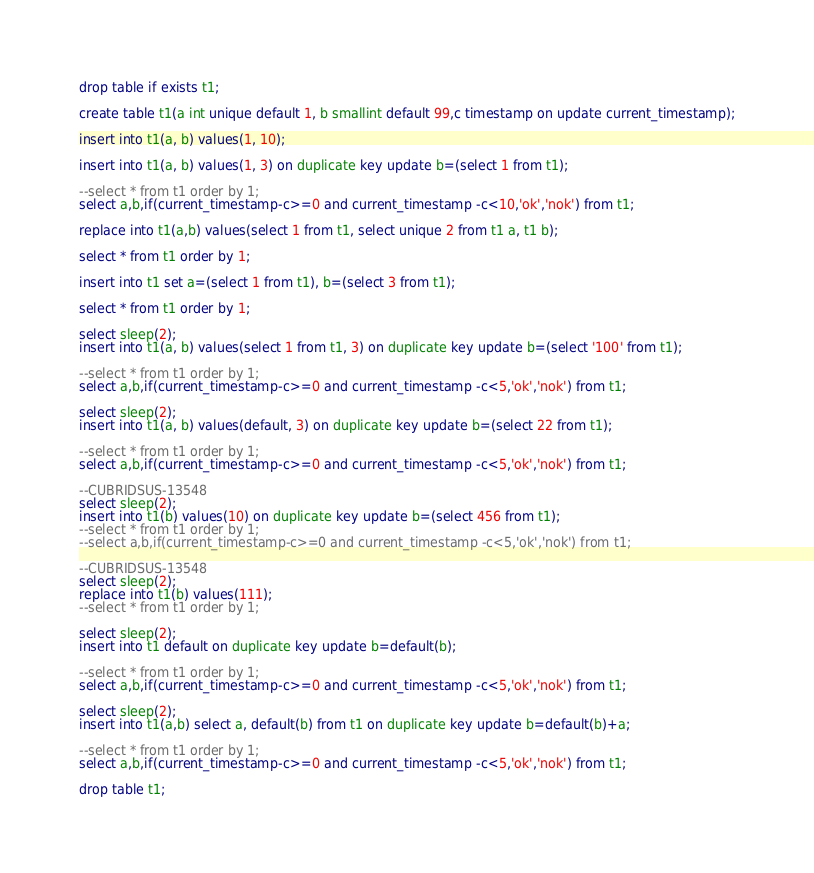Convert code to text. <code><loc_0><loc_0><loc_500><loc_500><_SQL_>drop table if exists t1;

create table t1(a int unique default 1, b smallint default 99,c timestamp on update current_timestamp);

insert into t1(a, b) values(1, 10);

insert into t1(a, b) values(1, 3) on duplicate key update b=(select 1 from t1);

--select * from t1 order by 1;
select a,b,if(current_timestamp-c>=0 and current_timestamp -c<10,'ok','nok') from t1;

replace into t1(a,b) values(select 1 from t1, select unique 2 from t1 a, t1 b);

select * from t1 order by 1;

insert into t1 set a=(select 1 from t1), b=(select 3 from t1);

select * from t1 order by 1;

select sleep(2);
insert into t1(a, b) values(select 1 from t1, 3) on duplicate key update b=(select '100' from t1);

--select * from t1 order by 1;
select a,b,if(current_timestamp-c>=0 and current_timestamp -c<5,'ok','nok') from t1;

select sleep(2);
insert into t1(a, b) values(default, 3) on duplicate key update b=(select 22 from t1);

--select * from t1 order by 1;
select a,b,if(current_timestamp-c>=0 and current_timestamp -c<5,'ok','nok') from t1;

--CUBRIDSUS-13548
select sleep(2);
insert into t1(b) values(10) on duplicate key update b=(select 456 from t1);
--select * from t1 order by 1;
--select a,b,if(current_timestamp-c>=0 and current_timestamp -c<5,'ok','nok') from t1;

--CUBRIDSUS-13548
select sleep(2);
replace into t1(b) values(111);
--select * from t1 order by 1;

select sleep(2);
insert into t1 default on duplicate key update b=default(b);

--select * from t1 order by 1;
select a,b,if(current_timestamp-c>=0 and current_timestamp -c<5,'ok','nok') from t1;

select sleep(2);
insert into t1(a,b) select a, default(b) from t1 on duplicate key update b=default(b)+a;

--select * from t1 order by 1;
select a,b,if(current_timestamp-c>=0 and current_timestamp -c<5,'ok','nok') from t1;

drop table t1;
</code> 